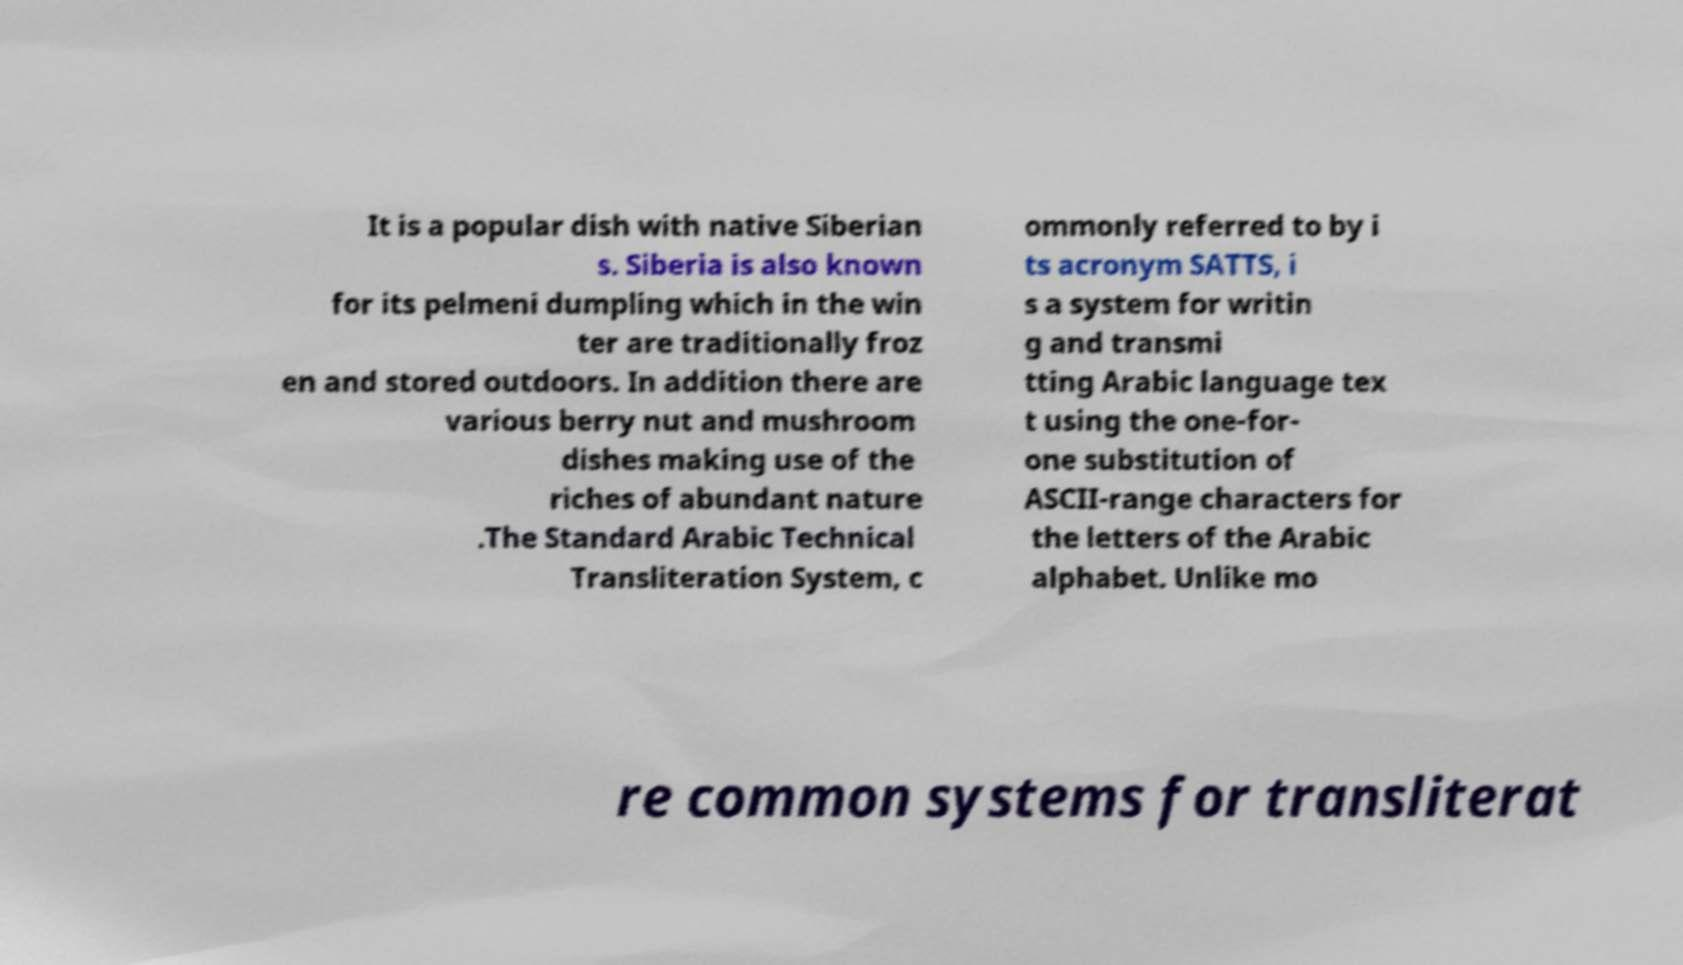What messages or text are displayed in this image? I need them in a readable, typed format. It is a popular dish with native Siberian s. Siberia is also known for its pelmeni dumpling which in the win ter are traditionally froz en and stored outdoors. In addition there are various berry nut and mushroom dishes making use of the riches of abundant nature .The Standard Arabic Technical Transliteration System, c ommonly referred to by i ts acronym SATTS, i s a system for writin g and transmi tting Arabic language tex t using the one-for- one substitution of ASCII-range characters for the letters of the Arabic alphabet. Unlike mo re common systems for transliterat 